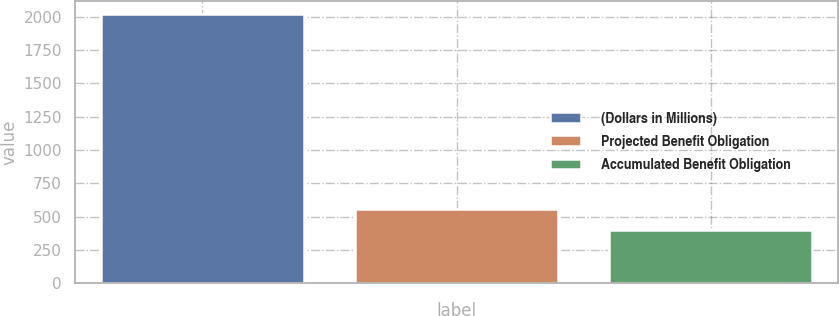Convert chart. <chart><loc_0><loc_0><loc_500><loc_500><bar_chart><fcel>(Dollars in Millions)<fcel>Projected Benefit Obligation<fcel>Accumulated Benefit Obligation<nl><fcel>2017<fcel>559<fcel>397<nl></chart> 